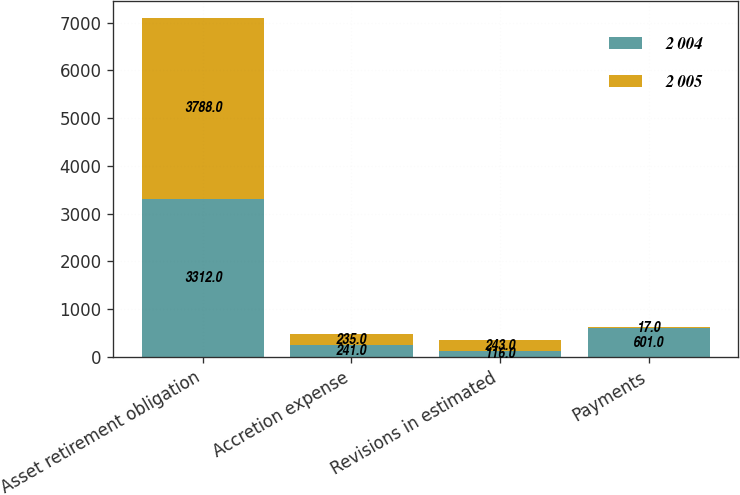<chart> <loc_0><loc_0><loc_500><loc_500><stacked_bar_chart><ecel><fcel>Asset retirement obligation<fcel>Accretion expense<fcel>Revisions in estimated<fcel>Payments<nl><fcel>2 004<fcel>3312<fcel>241<fcel>116<fcel>601<nl><fcel>2 005<fcel>3788<fcel>235<fcel>243<fcel>17<nl></chart> 